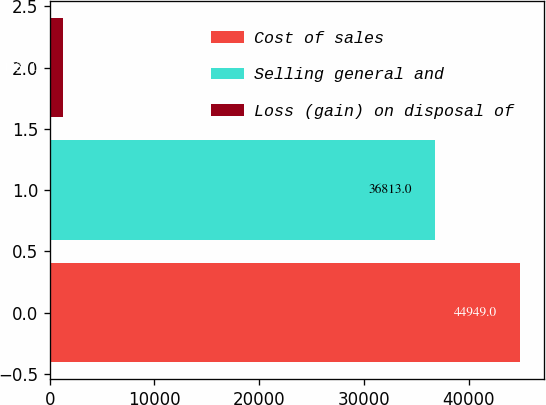<chart> <loc_0><loc_0><loc_500><loc_500><bar_chart><fcel>Cost of sales<fcel>Selling general and<fcel>Loss (gain) on disposal of<nl><fcel>44949<fcel>36813<fcel>1233<nl></chart> 